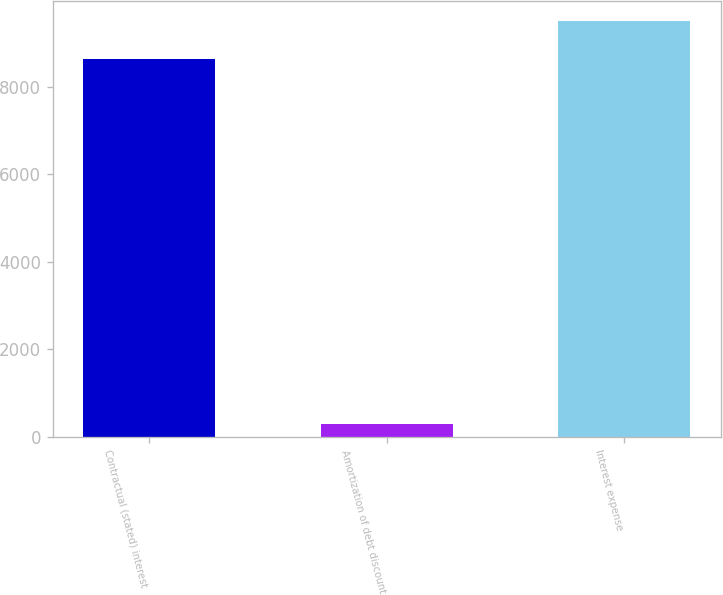Convert chart. <chart><loc_0><loc_0><loc_500><loc_500><bar_chart><fcel>Contractual (stated) interest<fcel>Amortization of debt discount<fcel>Interest expense<nl><fcel>8625<fcel>301<fcel>9487.5<nl></chart> 